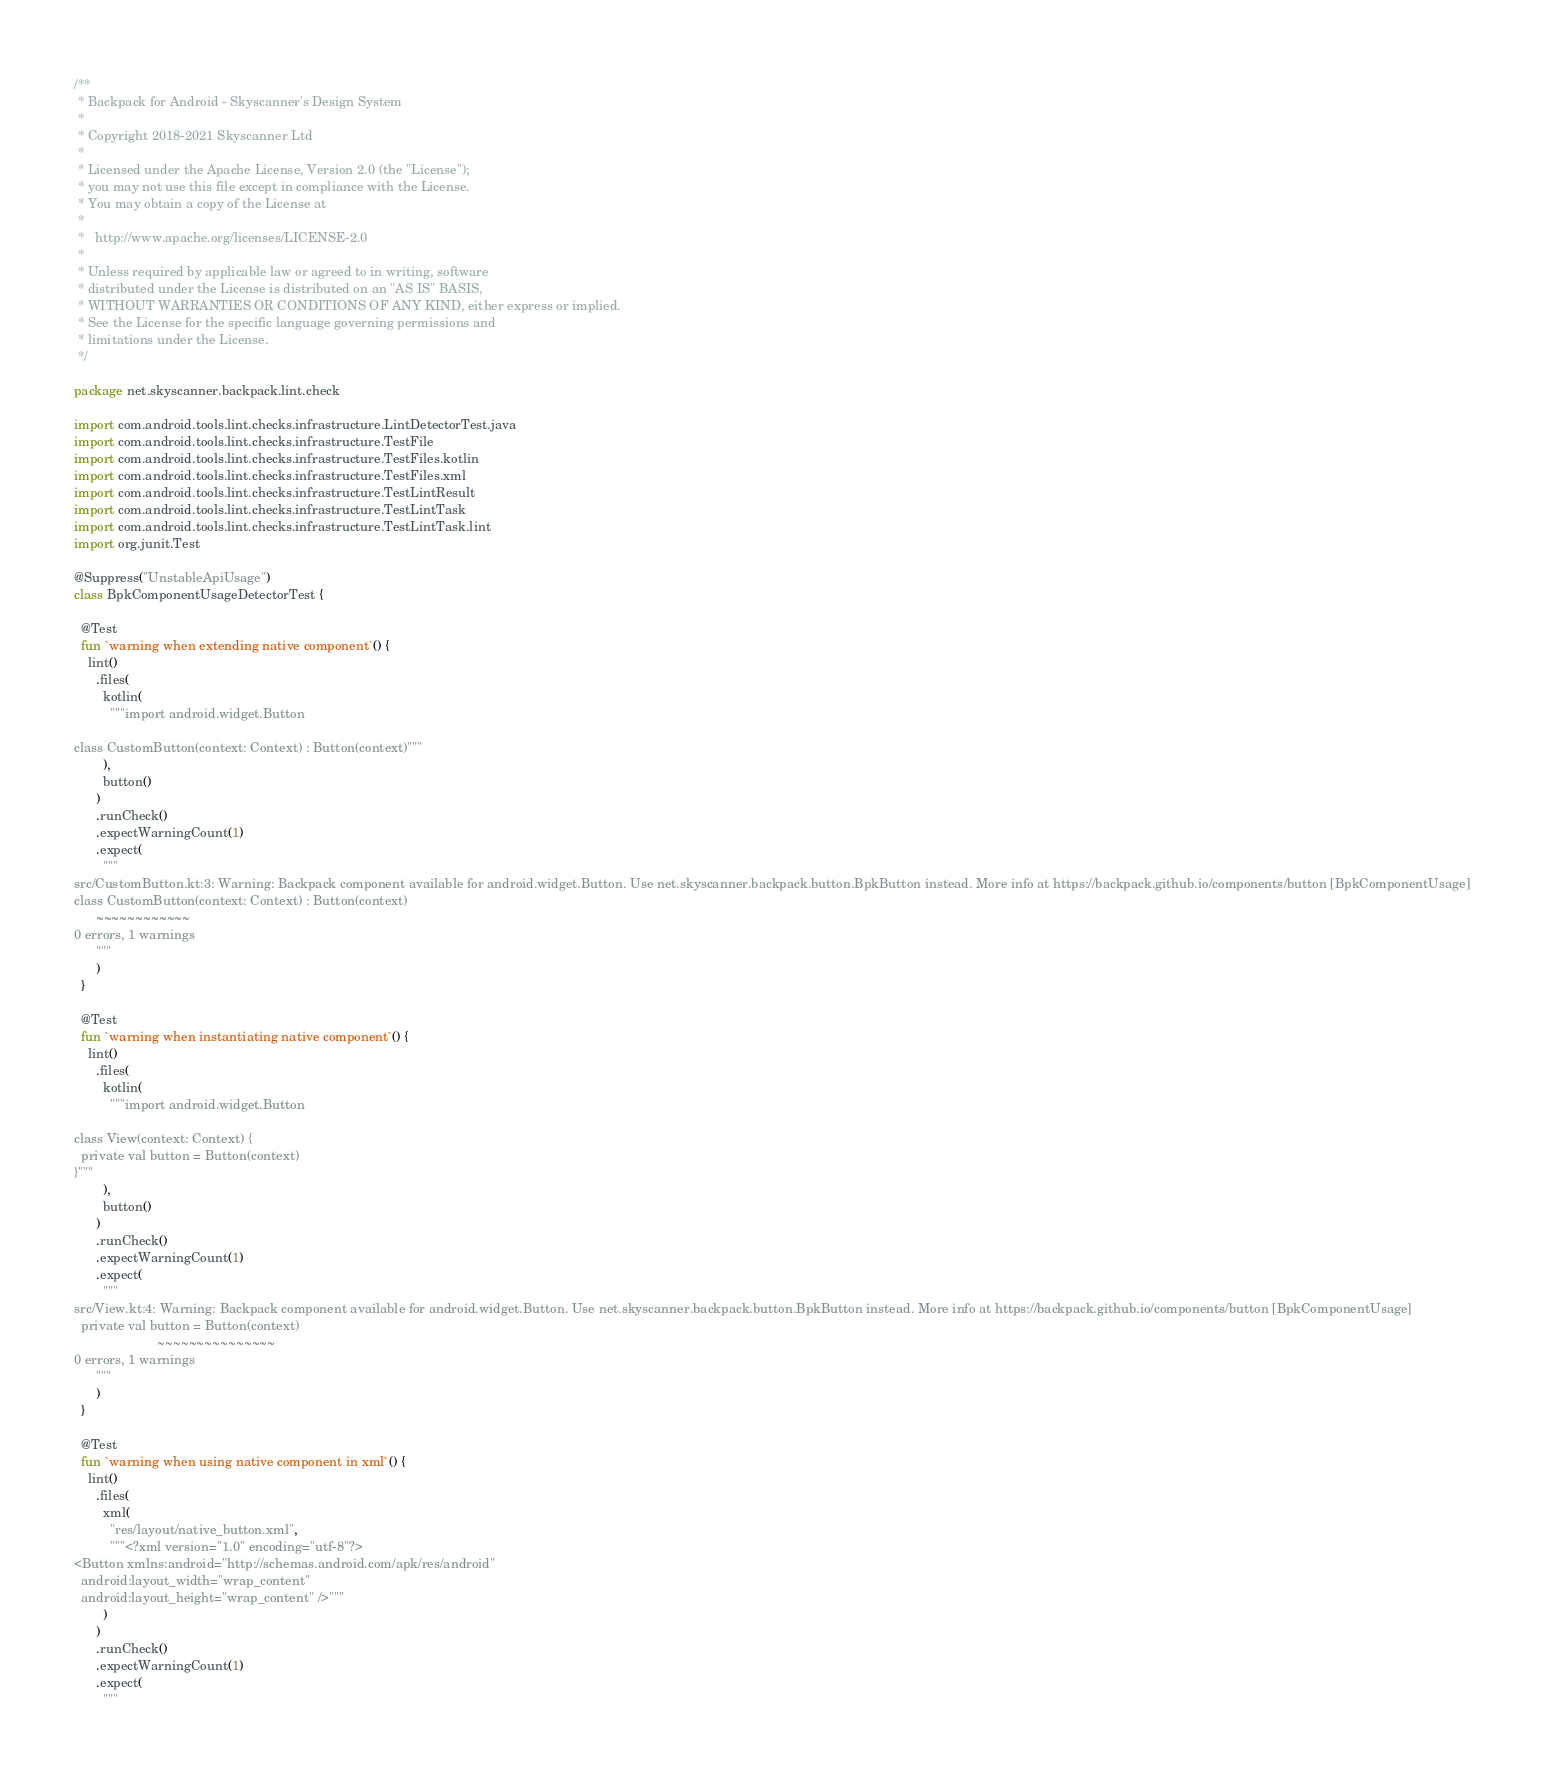<code> <loc_0><loc_0><loc_500><loc_500><_Kotlin_>/**
 * Backpack for Android - Skyscanner's Design System
 *
 * Copyright 2018-2021 Skyscanner Ltd
 *
 * Licensed under the Apache License, Version 2.0 (the "License");
 * you may not use this file except in compliance with the License.
 * You may obtain a copy of the License at
 *
 *   http://www.apache.org/licenses/LICENSE-2.0
 *
 * Unless required by applicable law or agreed to in writing, software
 * distributed under the License is distributed on an "AS IS" BASIS,
 * WITHOUT WARRANTIES OR CONDITIONS OF ANY KIND, either express or implied.
 * See the License for the specific language governing permissions and
 * limitations under the License.
 */

package net.skyscanner.backpack.lint.check

import com.android.tools.lint.checks.infrastructure.LintDetectorTest.java
import com.android.tools.lint.checks.infrastructure.TestFile
import com.android.tools.lint.checks.infrastructure.TestFiles.kotlin
import com.android.tools.lint.checks.infrastructure.TestFiles.xml
import com.android.tools.lint.checks.infrastructure.TestLintResult
import com.android.tools.lint.checks.infrastructure.TestLintTask
import com.android.tools.lint.checks.infrastructure.TestLintTask.lint
import org.junit.Test

@Suppress("UnstableApiUsage")
class BpkComponentUsageDetectorTest {

  @Test
  fun `warning when extending native component`() {
    lint()
      .files(
        kotlin(
          """import android.widget.Button

class CustomButton(context: Context) : Button(context)"""
        ),
        button()
      )
      .runCheck()
      .expectWarningCount(1)
      .expect(
        """
src/CustomButton.kt:3: Warning: Backpack component available for android.widget.Button. Use net.skyscanner.backpack.button.BpkButton instead. More info at https://backpack.github.io/components/button [BpkComponentUsage]
class CustomButton(context: Context) : Button(context)
      ~~~~~~~~~~~~
0 errors, 1 warnings
      """
      )
  }

  @Test
  fun `warning when instantiating native component`() {
    lint()
      .files(
        kotlin(
          """import android.widget.Button

class View(context: Context) {
  private val button = Button(context)
}"""
        ),
        button()
      )
      .runCheck()
      .expectWarningCount(1)
      .expect(
        """
src/View.kt:4: Warning: Backpack component available for android.widget.Button. Use net.skyscanner.backpack.button.BpkButton instead. More info at https://backpack.github.io/components/button [BpkComponentUsage]
  private val button = Button(context)
                       ~~~~~~~~~~~~~~~
0 errors, 1 warnings
      """
      )
  }

  @Test
  fun `warning when using native component in xml`() {
    lint()
      .files(
        xml(
          "res/layout/native_button.xml",
          """<?xml version="1.0" encoding="utf-8"?>
<Button xmlns:android="http://schemas.android.com/apk/res/android"
  android:layout_width="wrap_content"
  android:layout_height="wrap_content" />"""
        )
      )
      .runCheck()
      .expectWarningCount(1)
      .expect(
        """</code> 